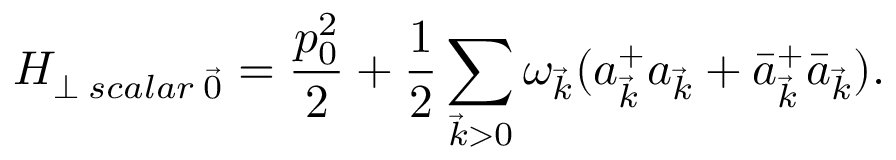Convert formula to latex. <formula><loc_0><loc_0><loc_500><loc_500>H _ { \perp \, s c a l a r \, \vec { 0 } } = \frac { p _ { 0 } ^ { 2 } } { 2 } + \frac { 1 } { 2 } \sum _ { \vec { k } > 0 } \omega _ { \vec { k } } ( a _ { \vec { k } } ^ { + } a _ { \vec { k } } + \bar { a } _ { \vec { k } } ^ { + } \bar { a } _ { \vec { k } } ) .</formula> 